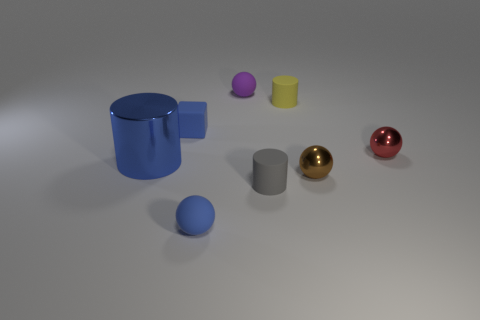What is the size of the sphere that is both behind the blue shiny thing and in front of the tiny purple rubber sphere?
Keep it short and to the point. Small. How many other objects are the same color as the matte block?
Provide a succinct answer. 2. Does the yellow cylinder have the same material as the tiny blue object that is in front of the blue cylinder?
Make the answer very short. Yes. How many objects are either tiny things behind the red sphere or tiny yellow rubber things?
Provide a succinct answer. 3. What shape is the rubber object that is behind the tiny block and on the left side of the tiny yellow rubber object?
Offer a very short reply. Sphere. Is there any other thing that has the same size as the yellow cylinder?
Give a very brief answer. Yes. There is a yellow object that is made of the same material as the blue ball; what size is it?
Your answer should be very brief. Small. What number of objects are cylinders left of the small purple sphere or balls that are in front of the small purple ball?
Your answer should be very brief. 4. Do the cylinder that is on the left side of the purple matte sphere and the blue matte cube have the same size?
Your answer should be very brief. No. There is a cylinder that is left of the blue matte ball; what is its color?
Your answer should be compact. Blue. 